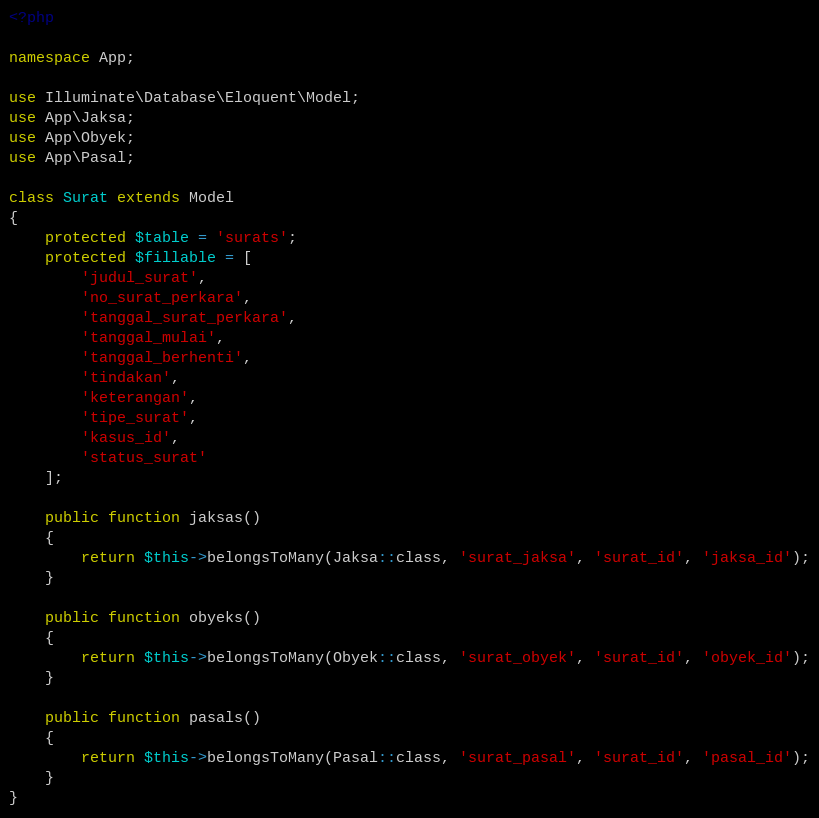<code> <loc_0><loc_0><loc_500><loc_500><_PHP_><?php

namespace App;

use Illuminate\Database\Eloquent\Model;
use App\Jaksa;
use App\Obyek;
use App\Pasal;

class Surat extends Model
{
	protected $table = 'surats';
    protected $fillable = [
    	'judul_surat', 
    	'no_surat_perkara', 
    	'tanggal_surat_perkara',
    	'tanggal_mulai',
    	'tanggal_berhenti',
        'tindakan',
        'keterangan',
    	'tipe_surat',
        'kasus_id',
        'status_surat'
    ];

    public function jaksas()
    {
        return $this->belongsToMany(Jaksa::class, 'surat_jaksa', 'surat_id', 'jaksa_id');
    }

    public function obyeks()
    {
        return $this->belongsToMany(Obyek::class, 'surat_obyek', 'surat_id', 'obyek_id');
    }

    public function pasals()
    {
        return $this->belongsToMany(Pasal::class, 'surat_pasal', 'surat_id', 'pasal_id');
    }
}
</code> 